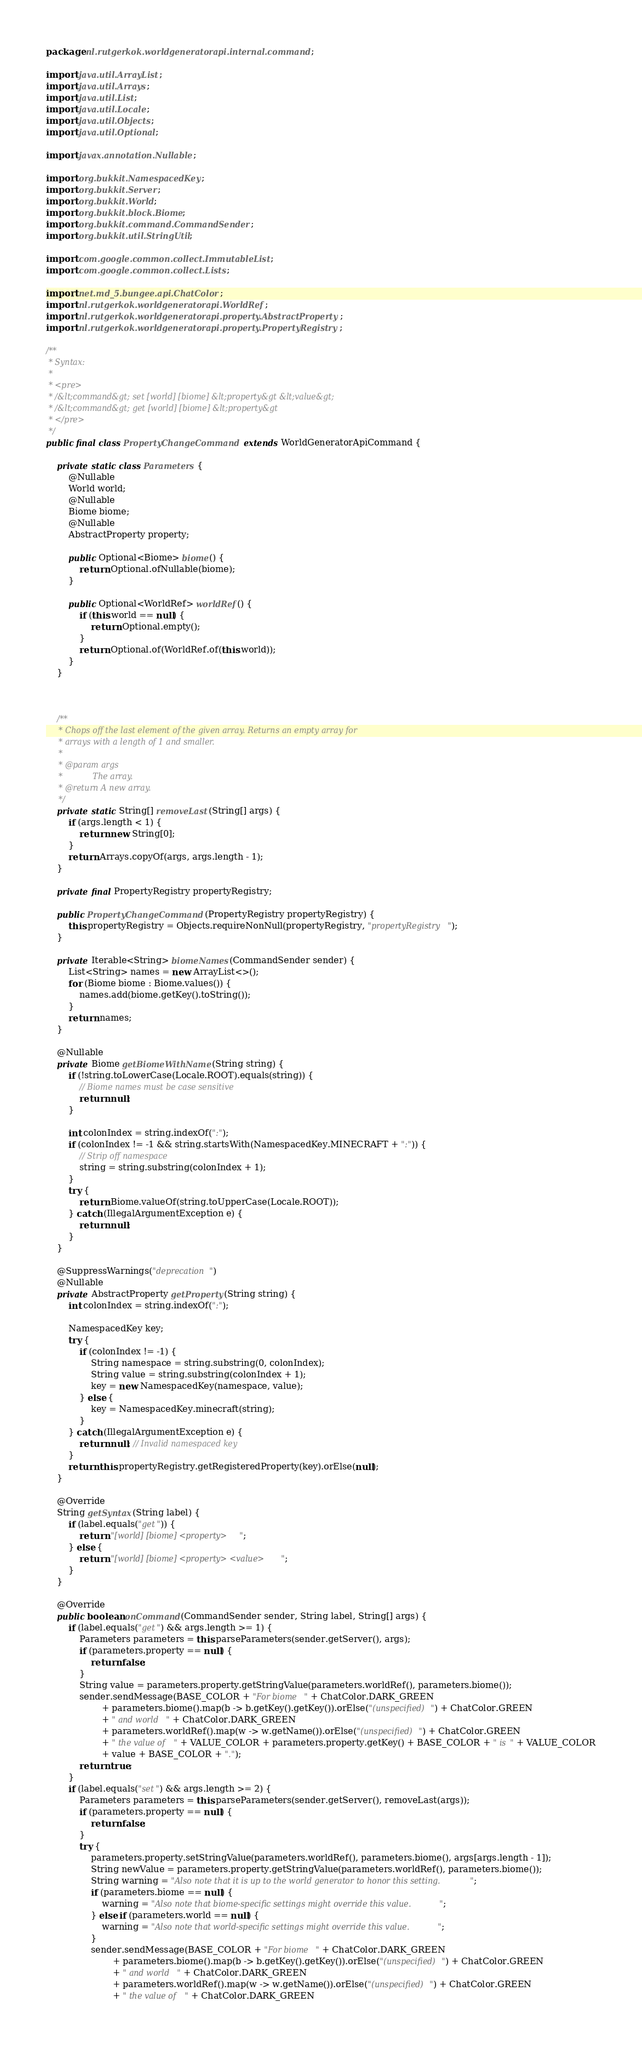Convert code to text. <code><loc_0><loc_0><loc_500><loc_500><_Java_>package nl.rutgerkok.worldgeneratorapi.internal.command;

import java.util.ArrayList;
import java.util.Arrays;
import java.util.List;
import java.util.Locale;
import java.util.Objects;
import java.util.Optional;

import javax.annotation.Nullable;

import org.bukkit.NamespacedKey;
import org.bukkit.Server;
import org.bukkit.World;
import org.bukkit.block.Biome;
import org.bukkit.command.CommandSender;
import org.bukkit.util.StringUtil;

import com.google.common.collect.ImmutableList;
import com.google.common.collect.Lists;

import net.md_5.bungee.api.ChatColor;
import nl.rutgerkok.worldgeneratorapi.WorldRef;
import nl.rutgerkok.worldgeneratorapi.property.AbstractProperty;
import nl.rutgerkok.worldgeneratorapi.property.PropertyRegistry;

/**
 * Syntax:
 *
 * <pre>
 * /&lt;command&gt; set [world] [biome] &lt;property&gt &lt;value&gt;
 * /&lt;command&gt; get [world] [biome] &lt;property&gt
 * </pre>
 */
public final class PropertyChangeCommand extends WorldGeneratorApiCommand {

    private static class Parameters {
        @Nullable
        World world;
        @Nullable
        Biome biome;
        @Nullable
        AbstractProperty property;

        public Optional<Biome> biome() {
            return Optional.ofNullable(biome);
        }

        public Optional<WorldRef> worldRef() {
            if (this.world == null) {
                return Optional.empty();
            }
            return Optional.of(WorldRef.of(this.world));
        }
    }



    /**
     * Chops off the last element of the given array. Returns an empty array for
     * arrays with a length of 1 and smaller.
     *
     * @param args
     *            The array.
     * @return A new array.
     */
    private static String[] removeLast(String[] args) {
        if (args.length < 1) {
            return new String[0];
        }
        return Arrays.copyOf(args, args.length - 1);
    }

    private final PropertyRegistry propertyRegistry;

    public PropertyChangeCommand(PropertyRegistry propertyRegistry) {
        this.propertyRegistry = Objects.requireNonNull(propertyRegistry, "propertyRegistry");
    }

    private Iterable<String> biomeNames(CommandSender sender) {
        List<String> names = new ArrayList<>();
        for (Biome biome : Biome.values()) {
            names.add(biome.getKey().toString());
        }
        return names;
    }

    @Nullable
    private Biome getBiomeWithName(String string) {
        if (!string.toLowerCase(Locale.ROOT).equals(string)) {
            // Biome names must be case sensitive
            return null;
        }

        int colonIndex = string.indexOf(":");
        if (colonIndex != -1 && string.startsWith(NamespacedKey.MINECRAFT + ":")) {
            // Strip off namespace
            string = string.substring(colonIndex + 1);
        }
        try {
            return Biome.valueOf(string.toUpperCase(Locale.ROOT));
        } catch (IllegalArgumentException e) {
            return null;
        }
    }

    @SuppressWarnings("deprecation")
    @Nullable
    private AbstractProperty getProperty(String string) {
        int colonIndex = string.indexOf(":");

        NamespacedKey key;
        try {
            if (colonIndex != -1) {
                String namespace = string.substring(0, colonIndex);
                String value = string.substring(colonIndex + 1);
                key = new NamespacedKey(namespace, value);
            } else {
                key = NamespacedKey.minecraft(string);
            }
        } catch (IllegalArgumentException e) {
            return null; // Invalid namespaced key
        }
        return this.propertyRegistry.getRegisteredProperty(key).orElse(null);
    }

    @Override
    String getSyntax(String label) {
        if (label.equals("get")) {
            return "[world] [biome] <property>";
        } else {
            return "[world] [biome] <property> <value>";
        }
    }

    @Override
    public boolean onCommand(CommandSender sender, String label, String[] args) {
        if (label.equals("get") && args.length >= 1) {
            Parameters parameters = this.parseParameters(sender.getServer(), args);
            if (parameters.property == null) {
                return false;
            }
            String value = parameters.property.getStringValue(parameters.worldRef(), parameters.biome());
            sender.sendMessage(BASE_COLOR + "For biome " + ChatColor.DARK_GREEN
                    + parameters.biome().map(b -> b.getKey().getKey()).orElse("(unspecified)") + ChatColor.GREEN
                    + " and world " + ChatColor.DARK_GREEN
                    + parameters.worldRef().map(w -> w.getName()).orElse("(unspecified)") + ChatColor.GREEN
                    + " the value of " + VALUE_COLOR + parameters.property.getKey() + BASE_COLOR + " is " + VALUE_COLOR
                    + value + BASE_COLOR + ".");
            return true;
        }
        if (label.equals("set") && args.length >= 2) {
            Parameters parameters = this.parseParameters(sender.getServer(), removeLast(args));
            if (parameters.property == null) {
                return false;
            }
            try {
                parameters.property.setStringValue(parameters.worldRef(), parameters.biome(), args[args.length - 1]);
                String newValue = parameters.property.getStringValue(parameters.worldRef(), parameters.biome());
                String warning = "Also note that it is up to the world generator to honor this setting.";
                if (parameters.biome == null) {
                    warning = "Also note that biome-specific settings might override this value.";
                } else if (parameters.world == null) {
                    warning = "Also note that world-specific settings might override this value.";
                }
                sender.sendMessage(BASE_COLOR + "For biome " + ChatColor.DARK_GREEN
                        + parameters.biome().map(b -> b.getKey().getKey()).orElse("(unspecified)") + ChatColor.GREEN
                        + " and world " + ChatColor.DARK_GREEN
                        + parameters.worldRef().map(w -> w.getName()).orElse("(unspecified)") + ChatColor.GREEN
                        + " the value of " + ChatColor.DARK_GREEN</code> 